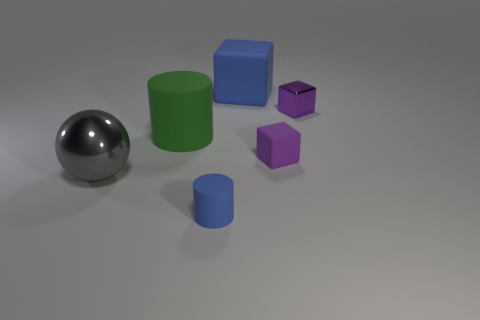What number of objects are large cylinders or blue rubber spheres?
Your answer should be very brief. 1. What is the shape of the big thing that is right of the large gray ball and on the left side of the big blue block?
Offer a terse response. Cylinder. Do the tiny purple metal thing and the blue rubber thing in front of the big blue block have the same shape?
Your answer should be very brief. No. There is a large matte cylinder; are there any cubes behind it?
Your answer should be compact. Yes. There is a small block that is the same color as the tiny metal thing; what is it made of?
Your response must be concise. Rubber. How many balls are either tiny purple metal objects or big blue matte objects?
Offer a very short reply. 0. Is the shape of the large green object the same as the purple rubber thing?
Provide a succinct answer. No. There is a matte thing that is on the left side of the tiny blue rubber cylinder; how big is it?
Your response must be concise. Large. Is there a large matte thing of the same color as the large shiny sphere?
Give a very brief answer. No. Is the size of the blue object to the left of the blue rubber cube the same as the large sphere?
Your answer should be very brief. No. 